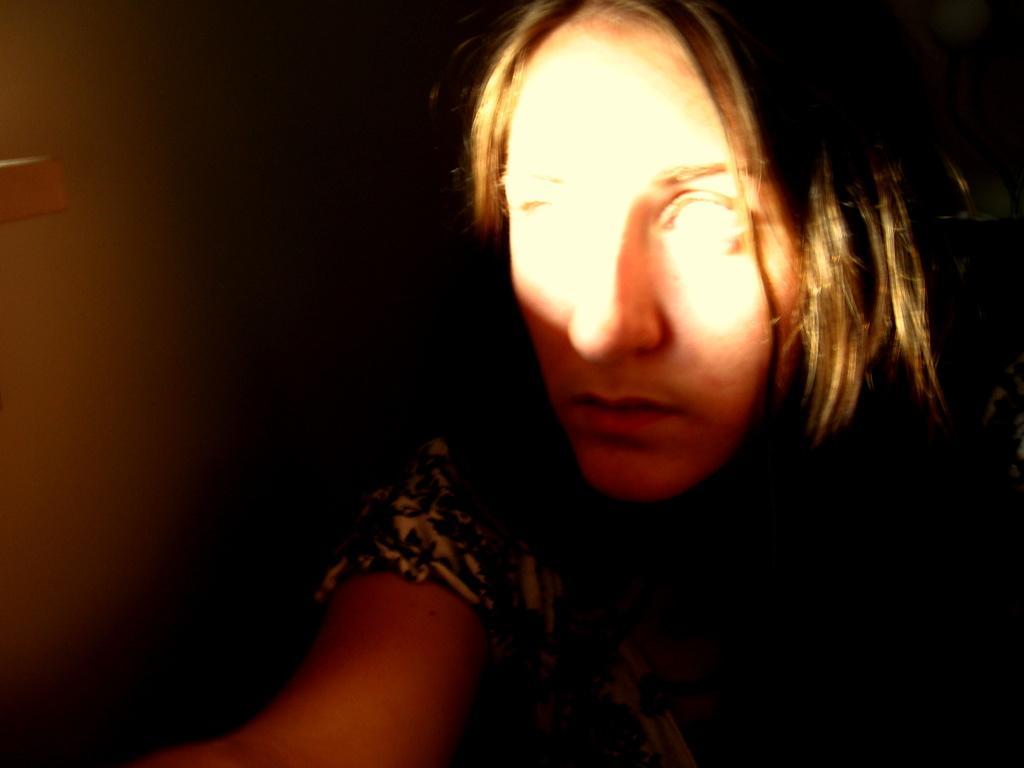Can you describe this image briefly? In this image there is light on the person face, and in the background there is wall. 